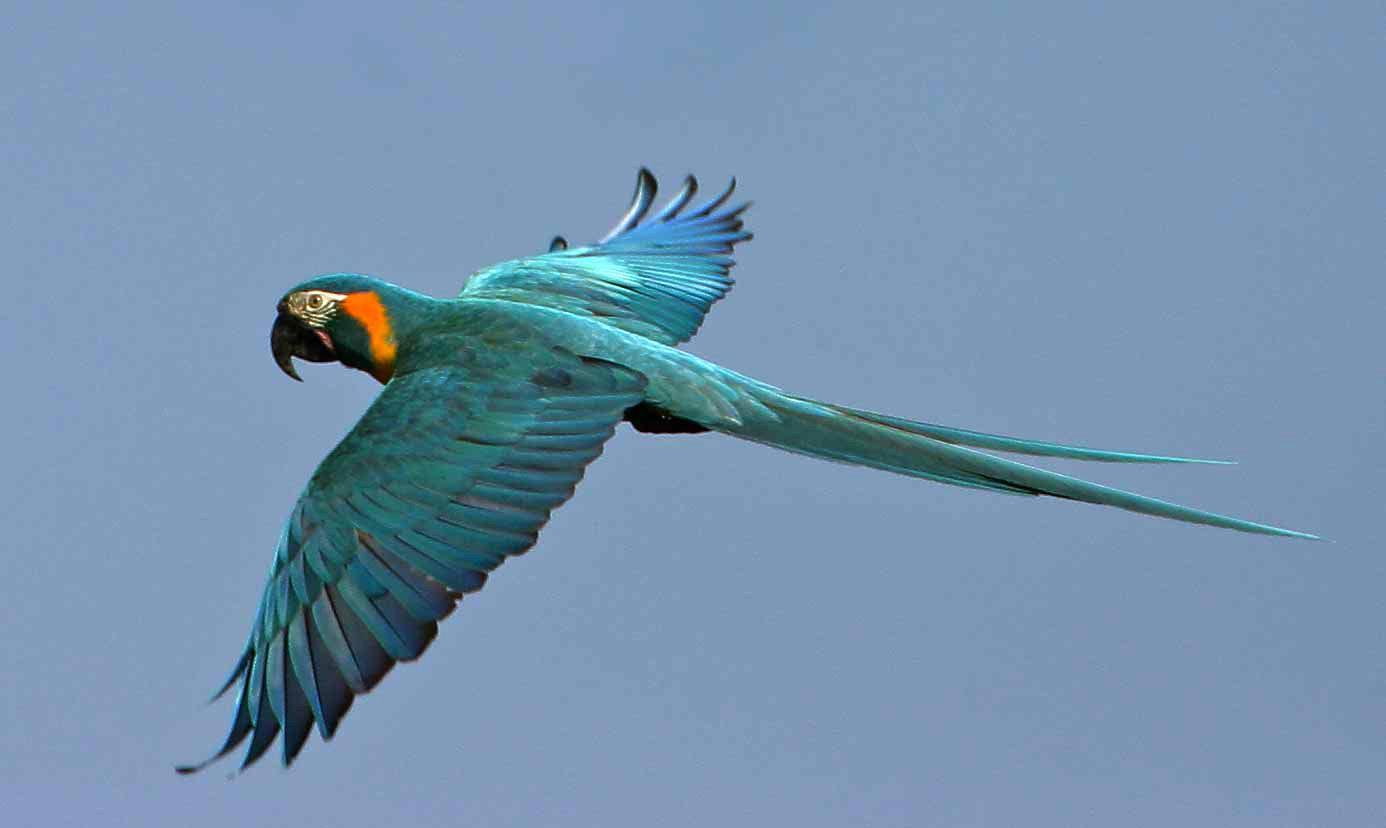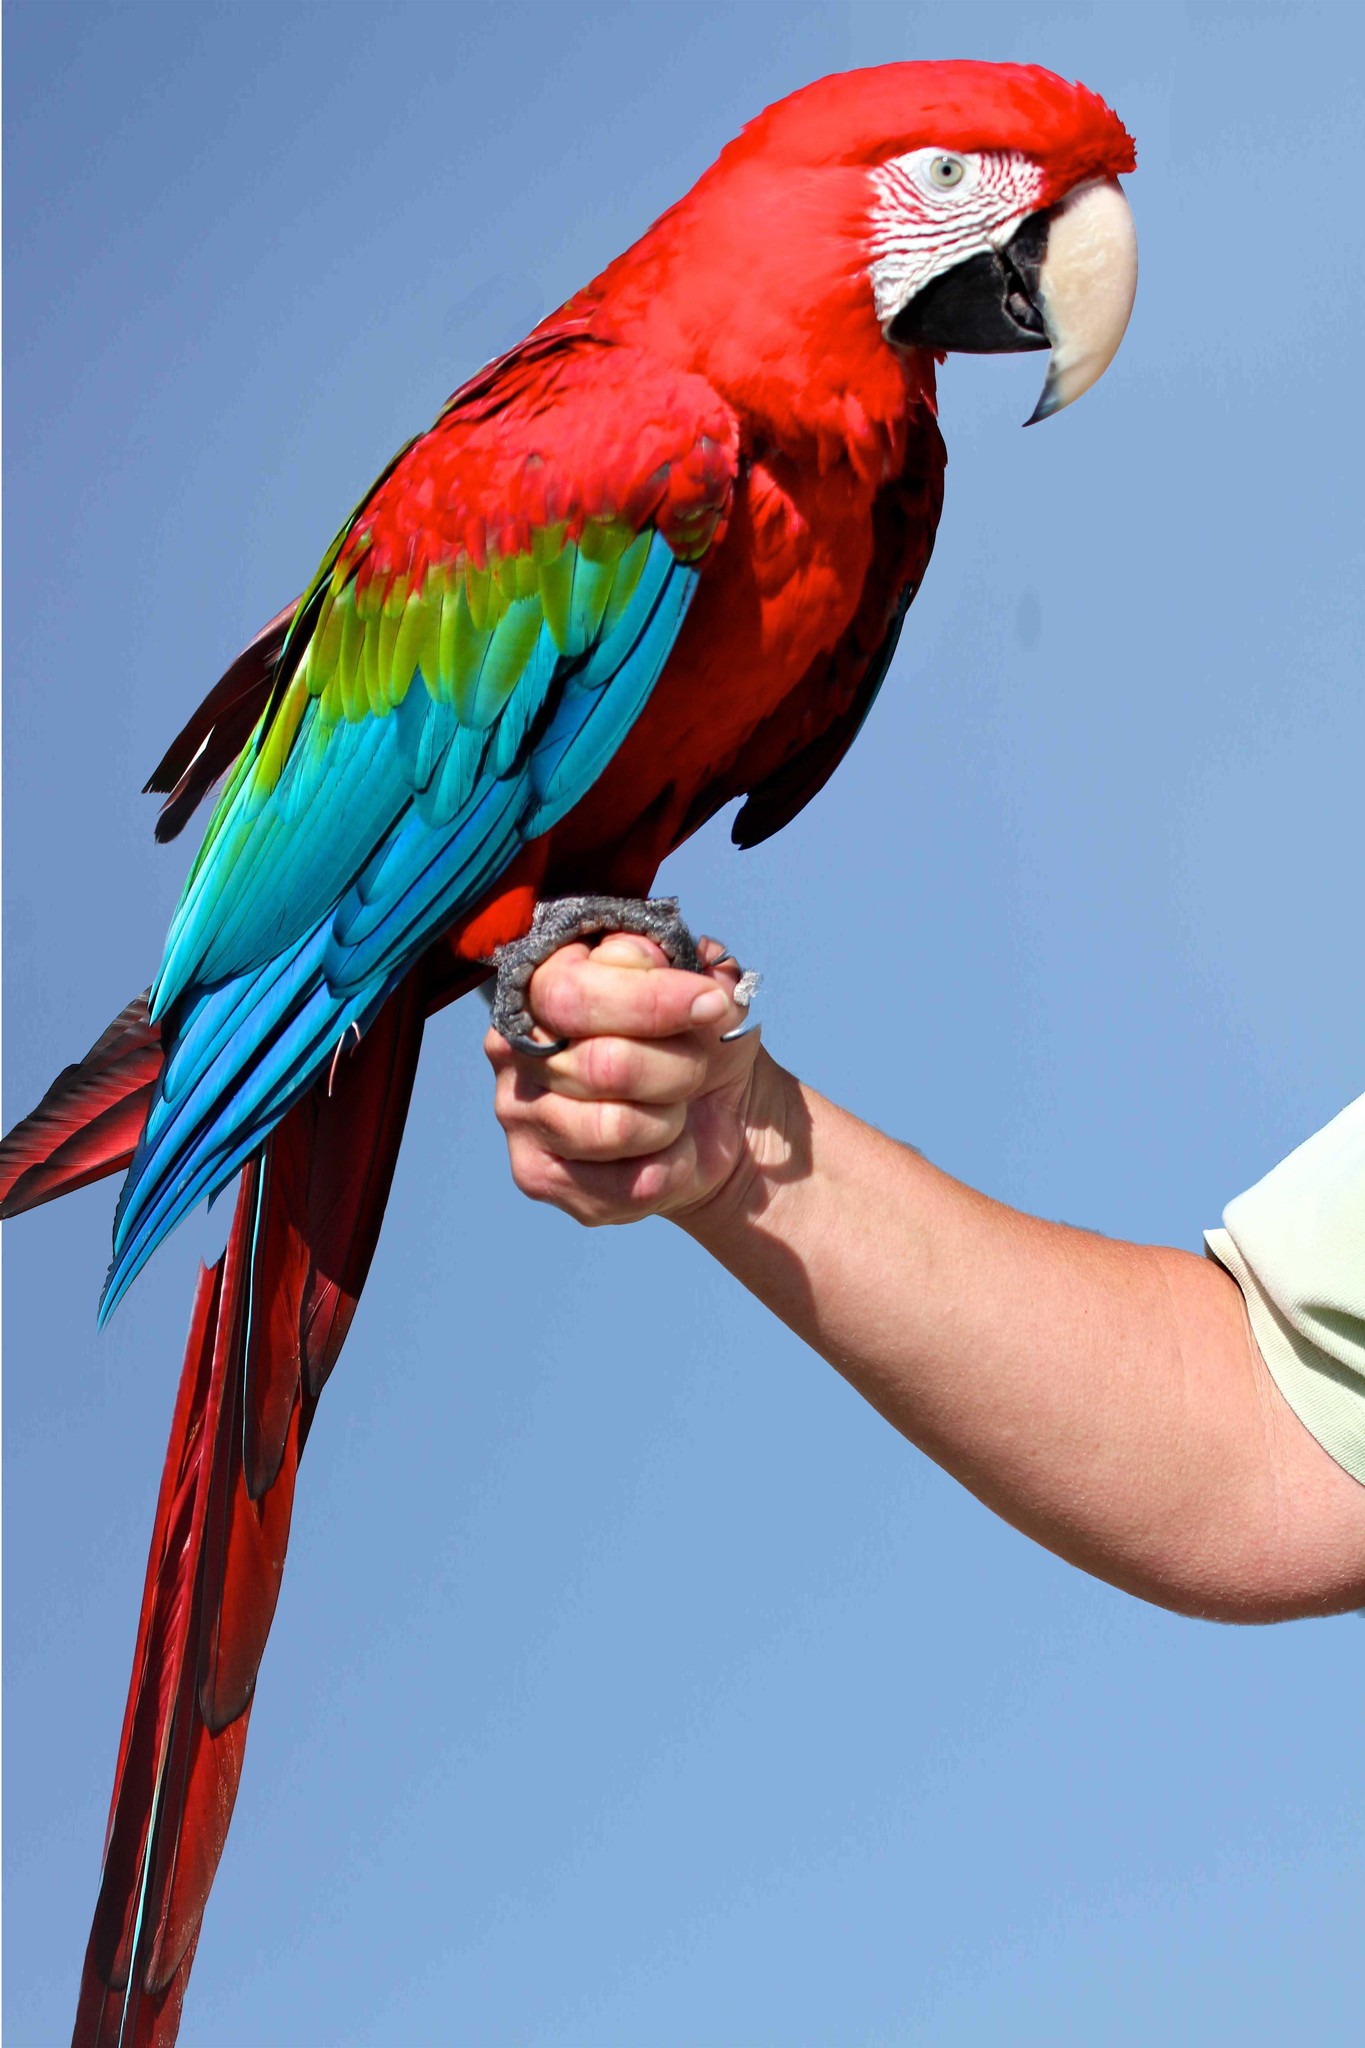The first image is the image on the left, the second image is the image on the right. Assess this claim about the two images: "There is at least one parrot perched on something rather than in flight". Correct or not? Answer yes or no. Yes. The first image is the image on the left, the second image is the image on the right. Considering the images on both sides, is "the birds are in flight showing their bellies" valid? Answer yes or no. No. 